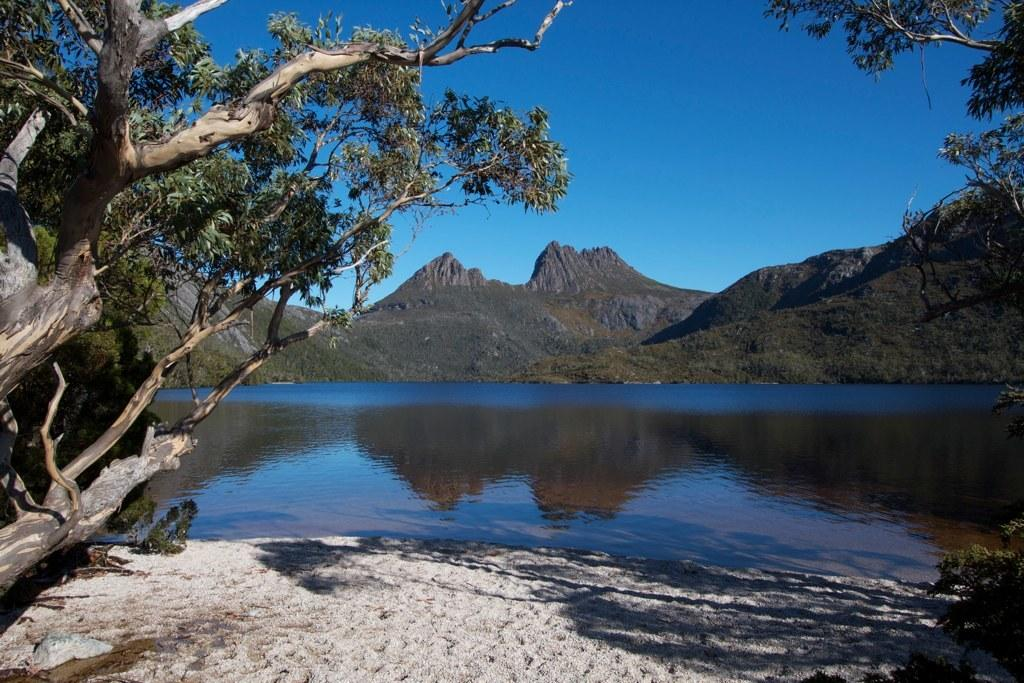What type of vegetation is at the bottom of the image? There are trees at the bottom of the image. What natural feature is in the center of the image? There is a river in the center of the image. What type of landscape can be seen in the background of the image? There are hills in the background of the image. What is visible in the sky in the image? The sky is visible in the background of the image, so we include it in the conversation to provide a complete description of the image. We start by identifying the main subjects and objects in the image based on the provided facts. We then formulate questions that focus on the location and characteristics of these subjects and objects, ensuring that each question can be answered definitively with the information given. We avoid yes/no questions and ensure that the language is simple and clear. Absurd Question/Answer: How many bears can be seen crossing the river in the image? There are no bears present in the image. What is the temperature drop in the image? There is no information about temperature or a temperature drop in the image. How many bears can be seen crossing the river in the image? There are no bears present in the image. What is the temperature drop in the image? There is no information about temperature or a temperature drop in the image. 